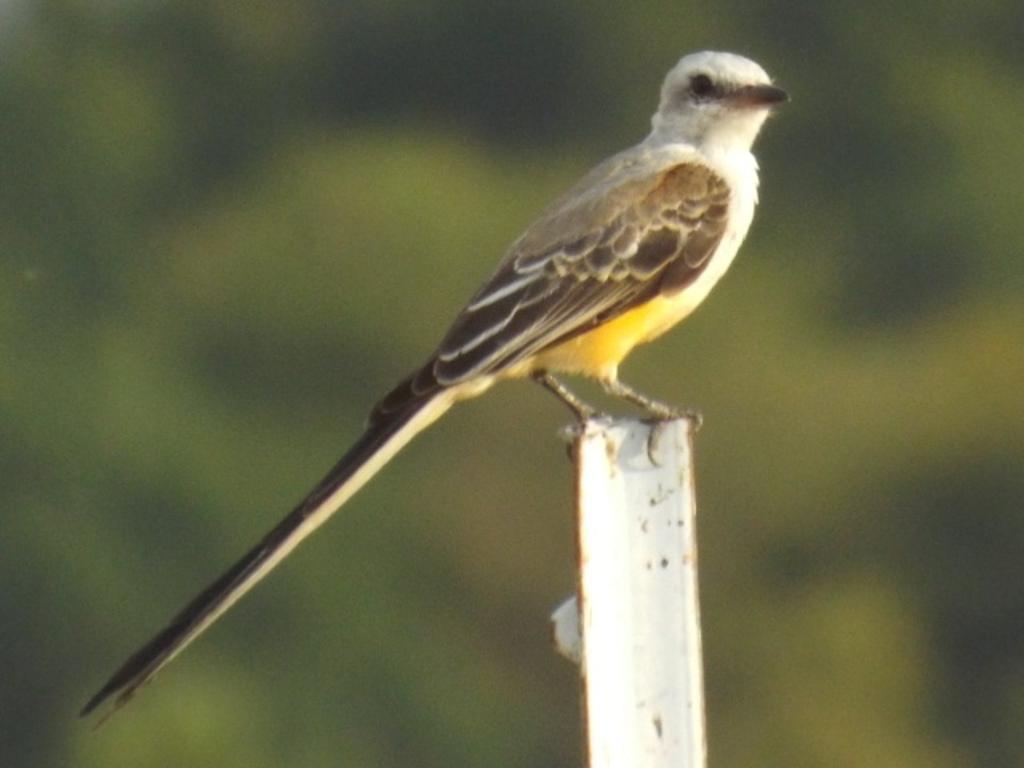In one or two sentences, can you explain what this image depicts? In this picture there is a small bird sitting on the iron rod. Behind there is a blur background. 